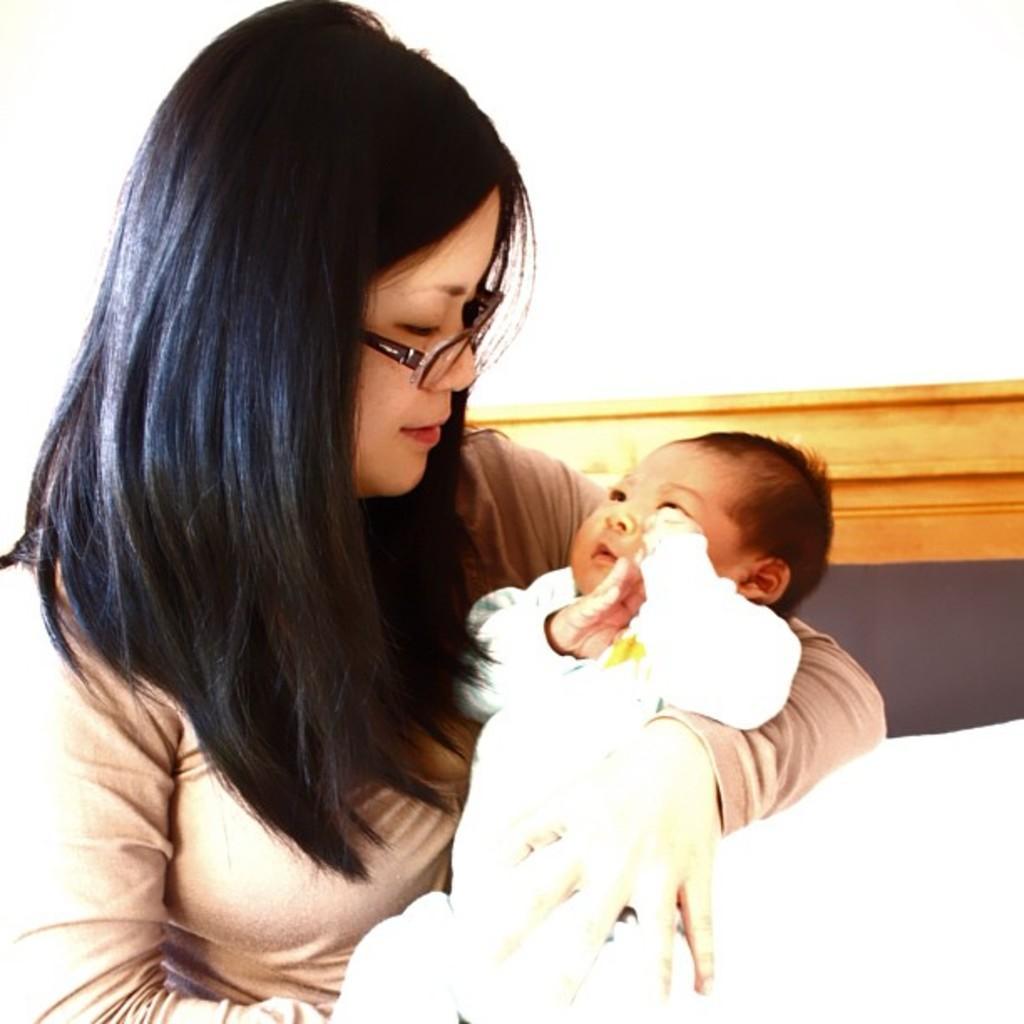In one or two sentences, can you explain what this image depicts? In the foreground of this image, there is a woman carrying a baby. Behind her, there is a wooden object and the white surface. 